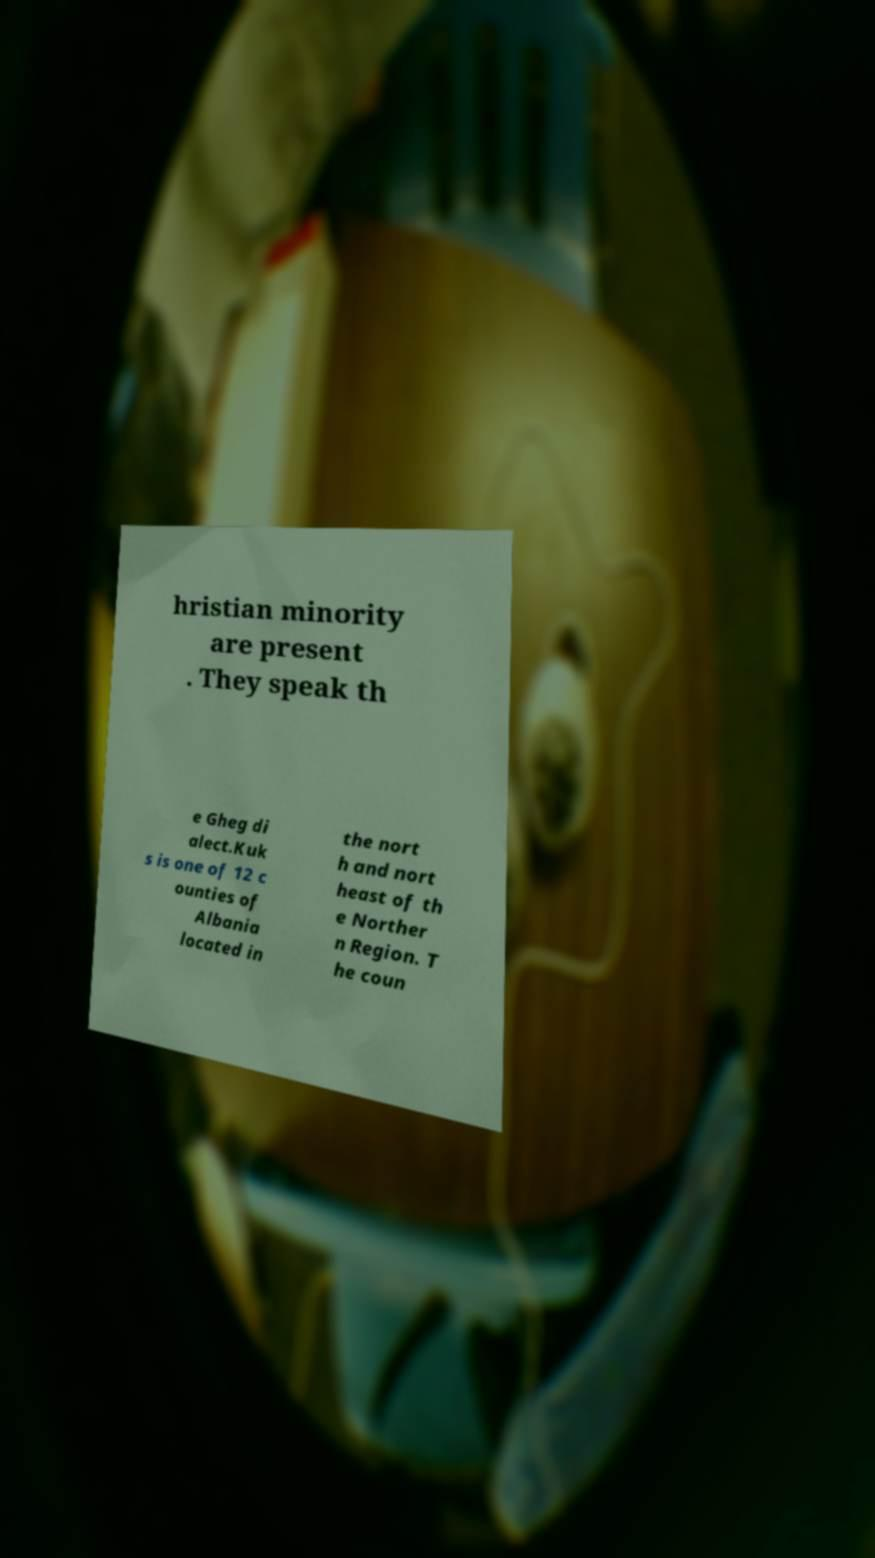Please identify and transcribe the text found in this image. hristian minority are present . They speak th e Gheg di alect.Kuk s is one of 12 c ounties of Albania located in the nort h and nort heast of th e Norther n Region. T he coun 